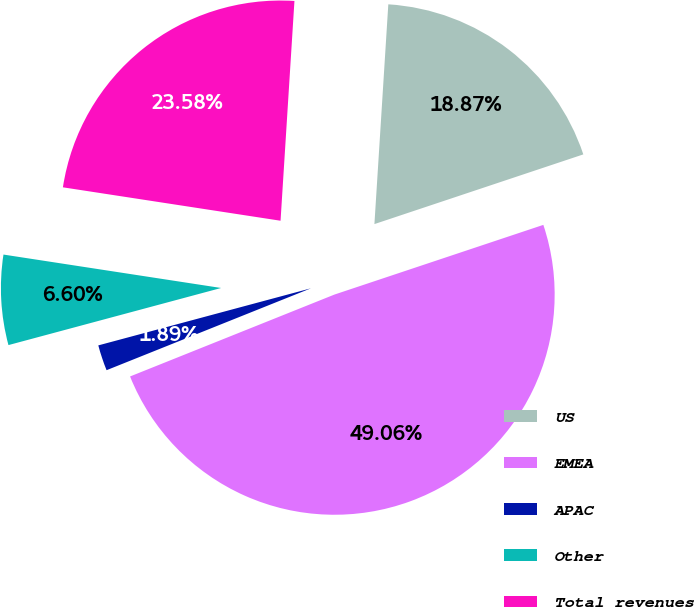Convert chart to OTSL. <chart><loc_0><loc_0><loc_500><loc_500><pie_chart><fcel>US<fcel>EMEA<fcel>APAC<fcel>Other<fcel>Total revenues<nl><fcel>18.87%<fcel>49.06%<fcel>1.89%<fcel>6.6%<fcel>23.58%<nl></chart> 